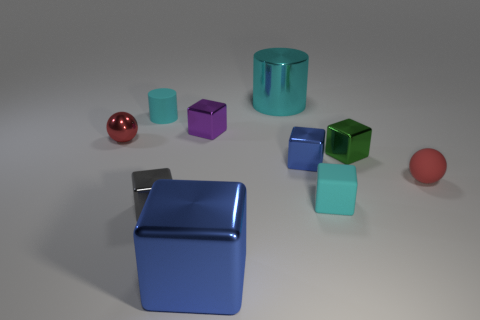Subtract all small cyan matte blocks. How many blocks are left? 5 Subtract 3 cubes. How many cubes are left? 3 Subtract all blue blocks. How many blocks are left? 4 Subtract all yellow blocks. Subtract all red cylinders. How many blocks are left? 6 Subtract all cylinders. How many objects are left? 8 Add 9 red matte objects. How many red matte objects exist? 10 Subtract 0 purple cylinders. How many objects are left? 10 Subtract all cyan cubes. Subtract all large purple shiny cylinders. How many objects are left? 9 Add 6 large cylinders. How many large cylinders are left? 7 